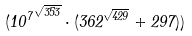Convert formula to latex. <formula><loc_0><loc_0><loc_500><loc_500>( { 1 0 ^ { 7 } } ^ { \sqrt { 3 5 3 } } \cdot ( 3 6 2 ^ { \sqrt { 4 2 9 } } + 2 9 7 ) )</formula> 